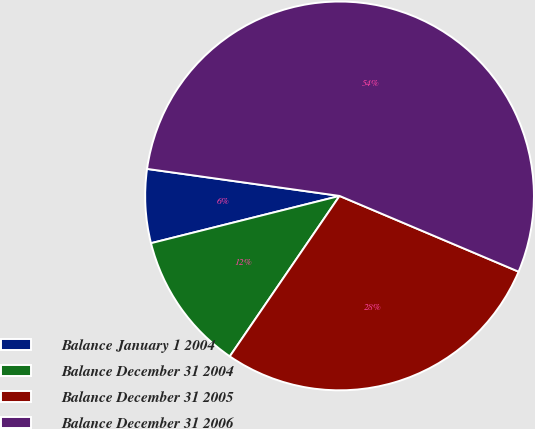Convert chart. <chart><loc_0><loc_0><loc_500><loc_500><pie_chart><fcel>Balance January 1 2004<fcel>Balance December 31 2004<fcel>Balance December 31 2005<fcel>Balance December 31 2006<nl><fcel>6.13%<fcel>11.54%<fcel>28.18%<fcel>54.15%<nl></chart> 